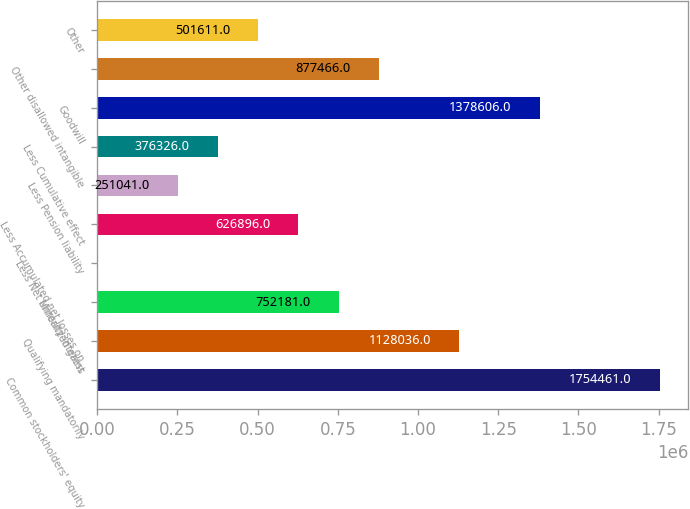Convert chart. <chart><loc_0><loc_0><loc_500><loc_500><bar_chart><fcel>Common stockholders' equity<fcel>Qualifying mandatorily<fcel>Minority interest<fcel>Less Net unrealized gains<fcel>Less Accumulated net losses on<fcel>Less Pension liability<fcel>Less Cumulative effect<fcel>Goodwill<fcel>Other disallowed intangible<fcel>Other<nl><fcel>1.75446e+06<fcel>1.12804e+06<fcel>752181<fcel>471<fcel>626896<fcel>251041<fcel>376326<fcel>1.37861e+06<fcel>877466<fcel>501611<nl></chart> 